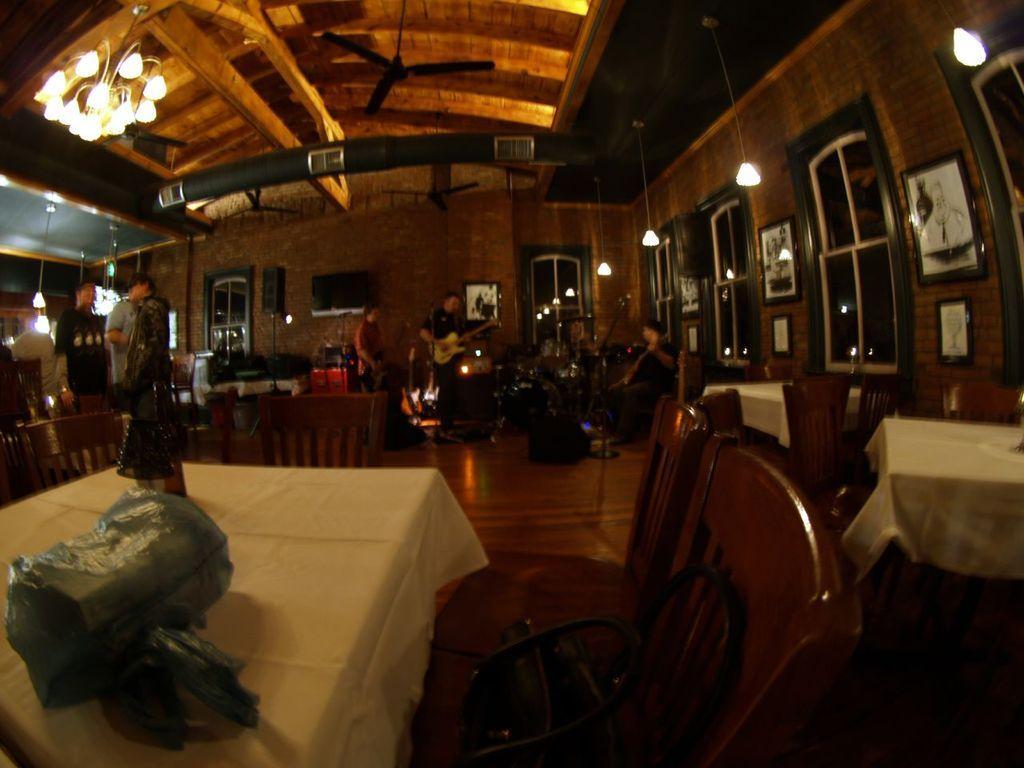Describe this image in one or two sentences. Here we can see tables and chairs. There are three persons playing musical instruments. This is floor. In the background we can see lights, windows, fans, frames, screen, and a wall. 